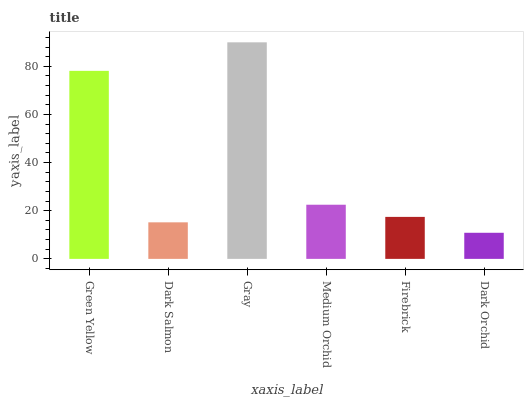Is Dark Orchid the minimum?
Answer yes or no. Yes. Is Gray the maximum?
Answer yes or no. Yes. Is Dark Salmon the minimum?
Answer yes or no. No. Is Dark Salmon the maximum?
Answer yes or no. No. Is Green Yellow greater than Dark Salmon?
Answer yes or no. Yes. Is Dark Salmon less than Green Yellow?
Answer yes or no. Yes. Is Dark Salmon greater than Green Yellow?
Answer yes or no. No. Is Green Yellow less than Dark Salmon?
Answer yes or no. No. Is Medium Orchid the high median?
Answer yes or no. Yes. Is Firebrick the low median?
Answer yes or no. Yes. Is Green Yellow the high median?
Answer yes or no. No. Is Dark Salmon the low median?
Answer yes or no. No. 